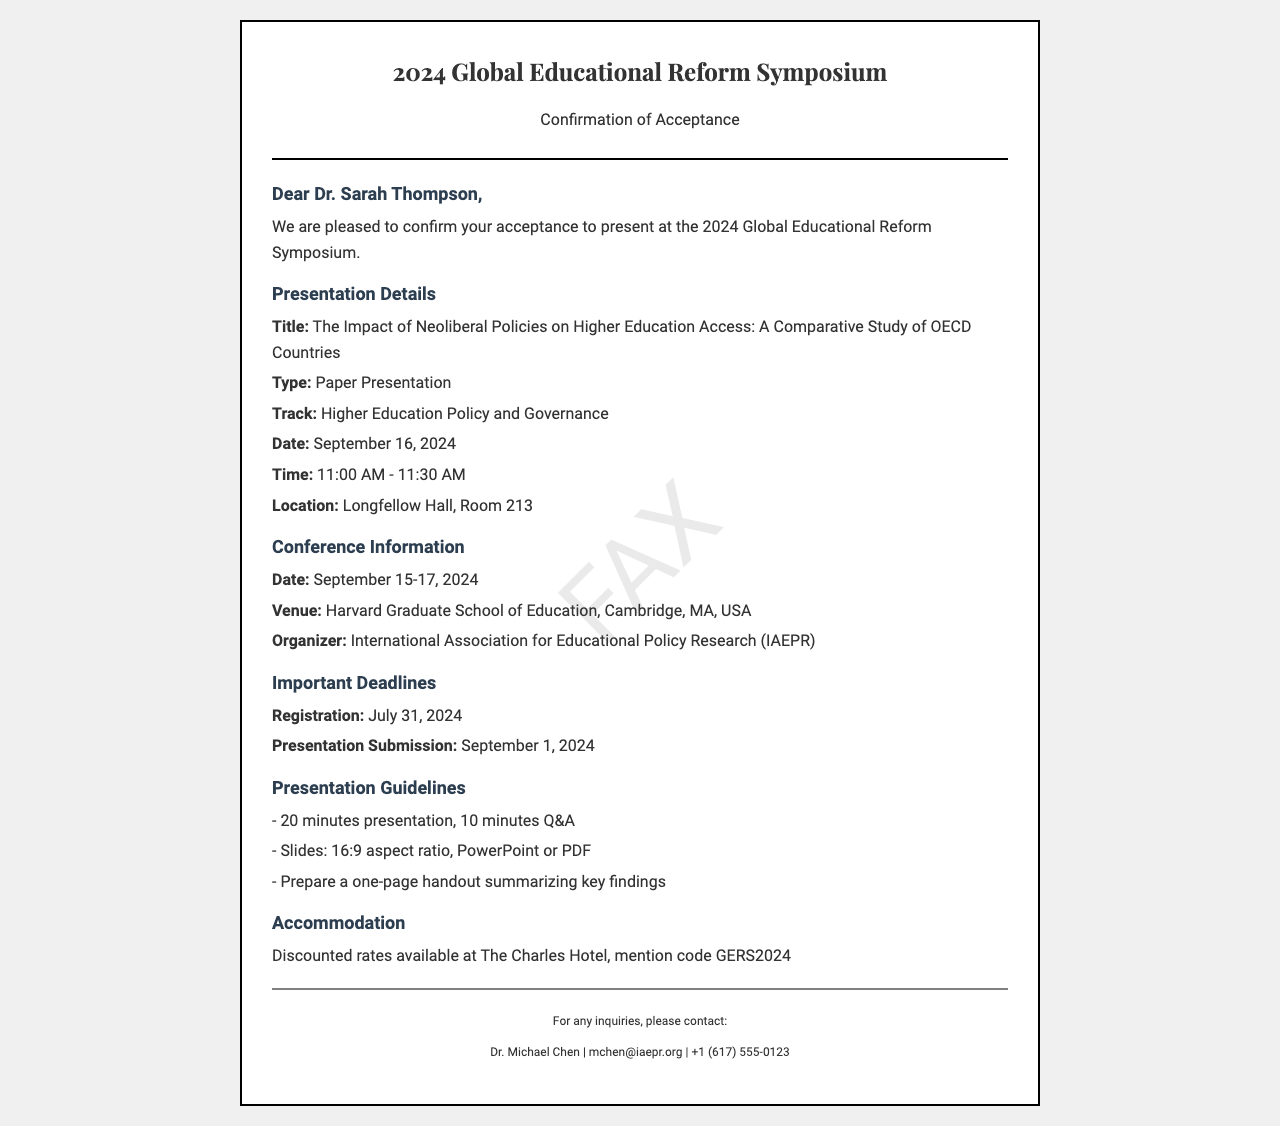What is the title of the presentation? The title of the presentation is stated in the document as "The Impact of Neoliberal Policies on Higher Education Access: A Comparative Study of OECD Countries."
Answer: The Impact of Neoliberal Policies on Higher Education Access: A Comparative Study of OECD Countries What is the date of the conference? The date of the conference is provided in the document as September 15-17, 2024.
Answer: September 15-17, 2024 What is the presentation duration? The duration of the presentation is mentioned as 20 minutes, followed by 10 minutes for Q&A.
Answer: 20 minutes Where is the conference venue located? The conference venue is listed as Harvard Graduate School of Education, Cambridge, MA, USA.
Answer: Harvard Graduate School of Education, Cambridge, MA, USA What is the registration deadline? The registration deadline is specified in the document as July 31, 2024.
Answer: July 31, 2024 What is the contact person's name? The contact person's name is given as Dr. Michael Chen in the footer of the document.
Answer: Dr. Michael Chen What type of presentation is Dr. Sarah Thompson giving? The document specifies that Dr. Sarah Thompson is giving a "Paper Presentation."
Answer: Paper Presentation How long before the presentation submission must be done? Presentation submission must be completed by September 1, 2024, which is 15 days before the conference.
Answer: 15 days What is the code for discounted accommodation? The code provided for discounted rates at The Charles Hotel is "GERS2024."
Answer: GERS2024 